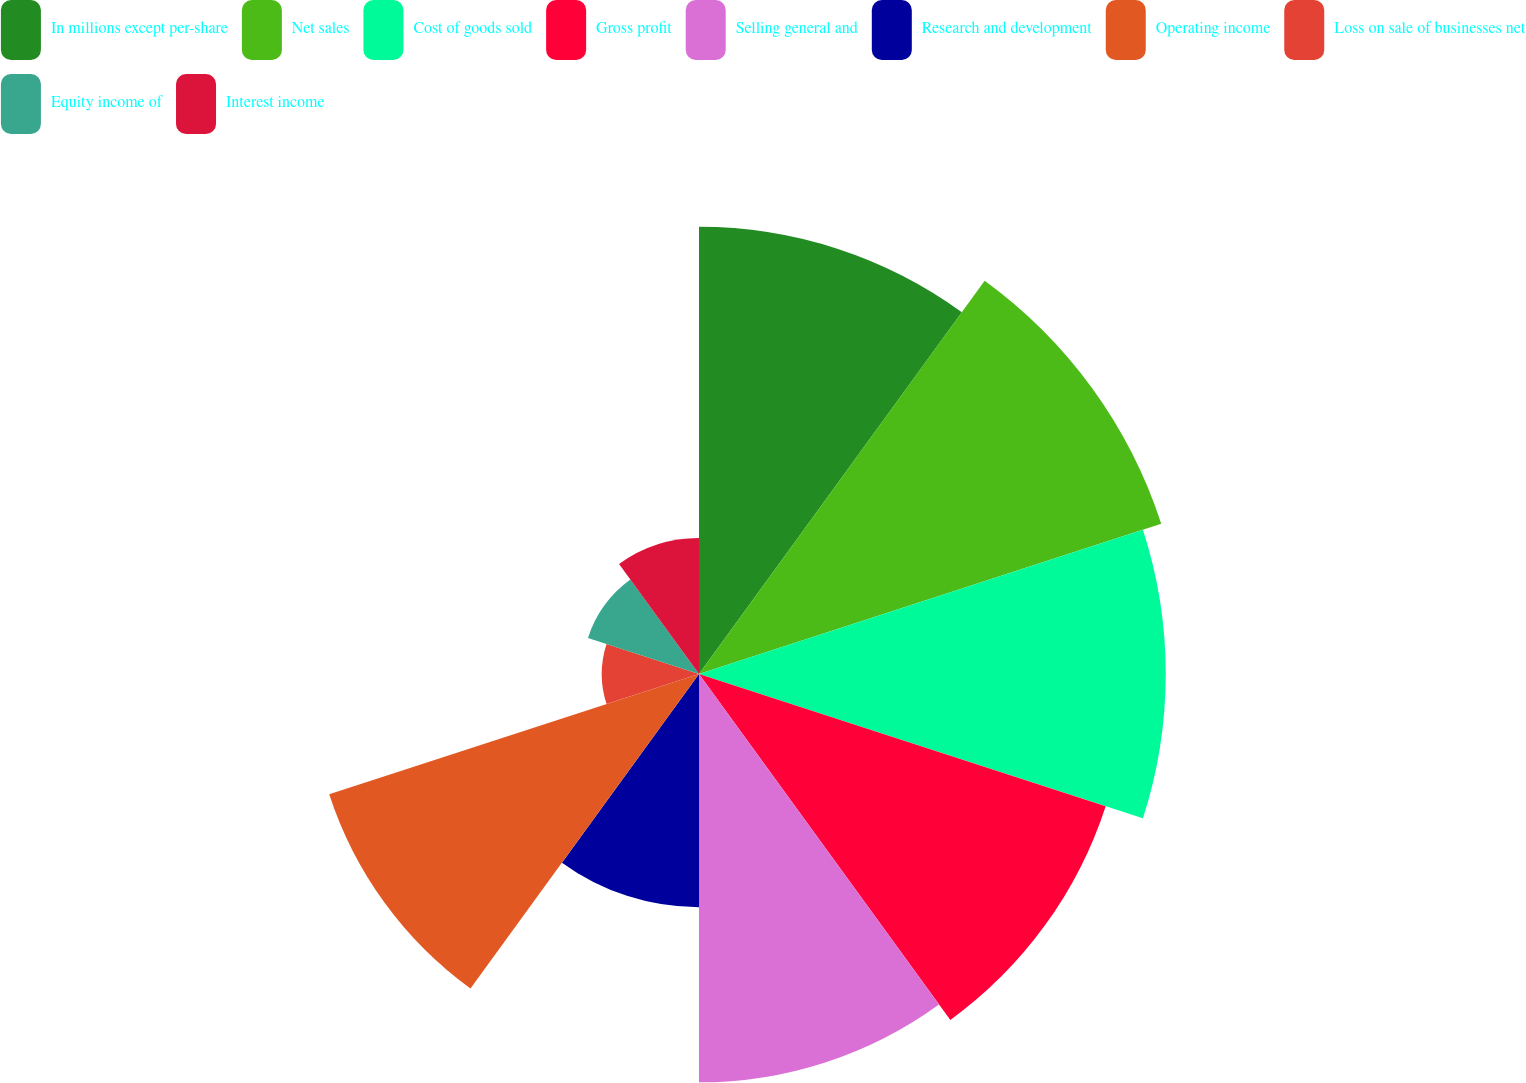Convert chart to OTSL. <chart><loc_0><loc_0><loc_500><loc_500><pie_chart><fcel>In millions except per-share<fcel>Net sales<fcel>Cost of goods sold<fcel>Gross profit<fcel>Selling general and<fcel>Research and development<fcel>Operating income<fcel>Loss on sale of businesses net<fcel>Equity income of<fcel>Interest income<nl><fcel>13.94%<fcel>15.15%<fcel>14.55%<fcel>13.33%<fcel>12.73%<fcel>7.27%<fcel>12.12%<fcel>3.03%<fcel>3.64%<fcel>4.24%<nl></chart> 